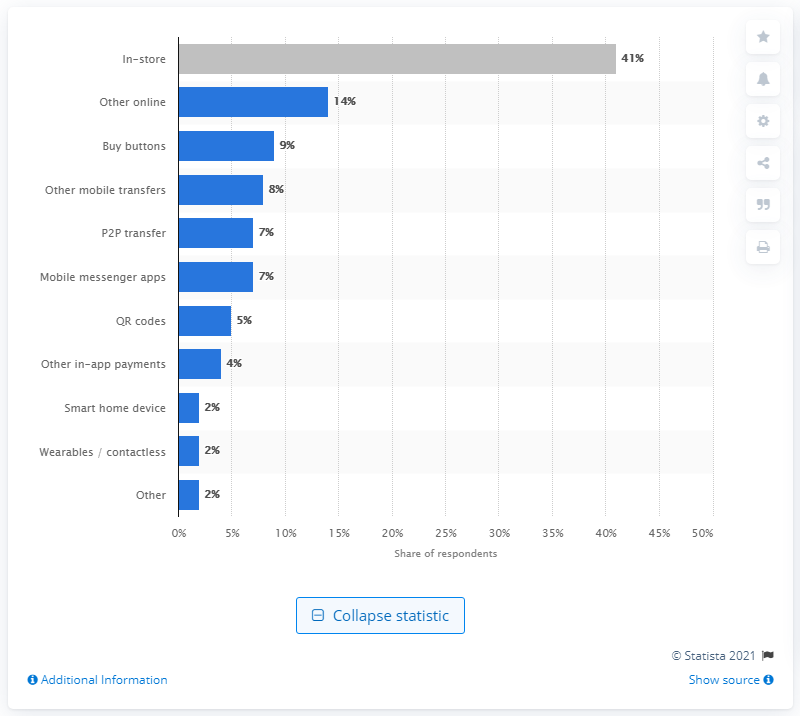List a handful of essential elements in this visual. According to data, approximately 41% of daily transactions were made in stores in a given period. 